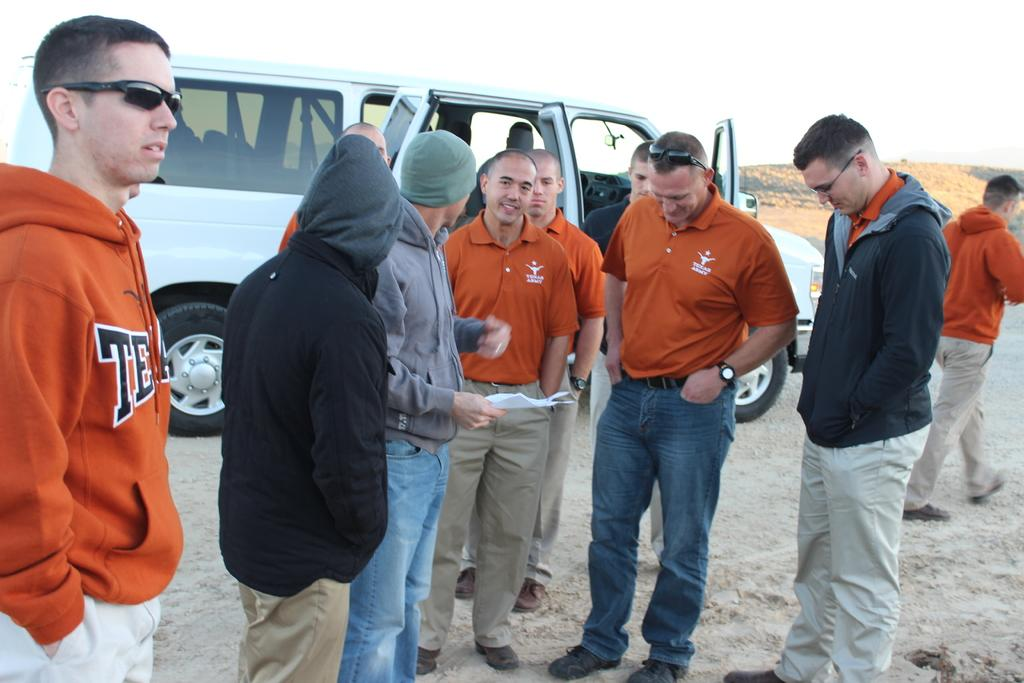What is at the bottom of the image? There is ground at the bottom of the image. Who or what can be seen in the image? There are people in the image. What is located in the foreground of the image? There is a vehicle in the foreground of the image. What is visible at the top of the image? There is sky visible at the top of the image. Can you see any lettuce in the image? There is no lettuce present in the image. Is there a gun visible in the image? There is no gun visible in the image. 